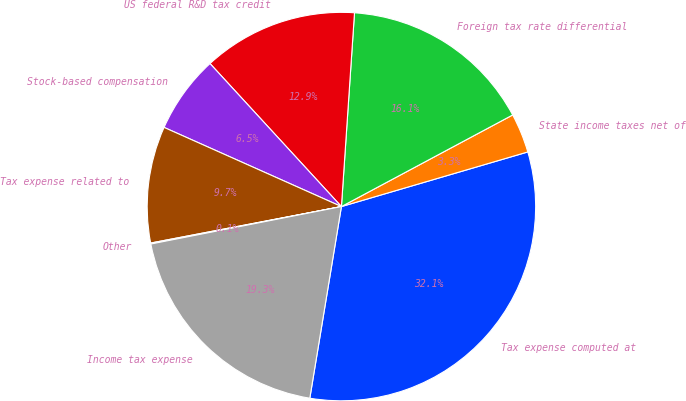Convert chart. <chart><loc_0><loc_0><loc_500><loc_500><pie_chart><fcel>Tax expense computed at<fcel>State income taxes net of<fcel>Foreign tax rate differential<fcel>US federal R&D tax credit<fcel>Stock-based compensation<fcel>Tax expense related to<fcel>Other<fcel>Income tax expense<nl><fcel>32.14%<fcel>3.28%<fcel>16.11%<fcel>12.9%<fcel>6.49%<fcel>9.69%<fcel>0.08%<fcel>19.31%<nl></chart> 